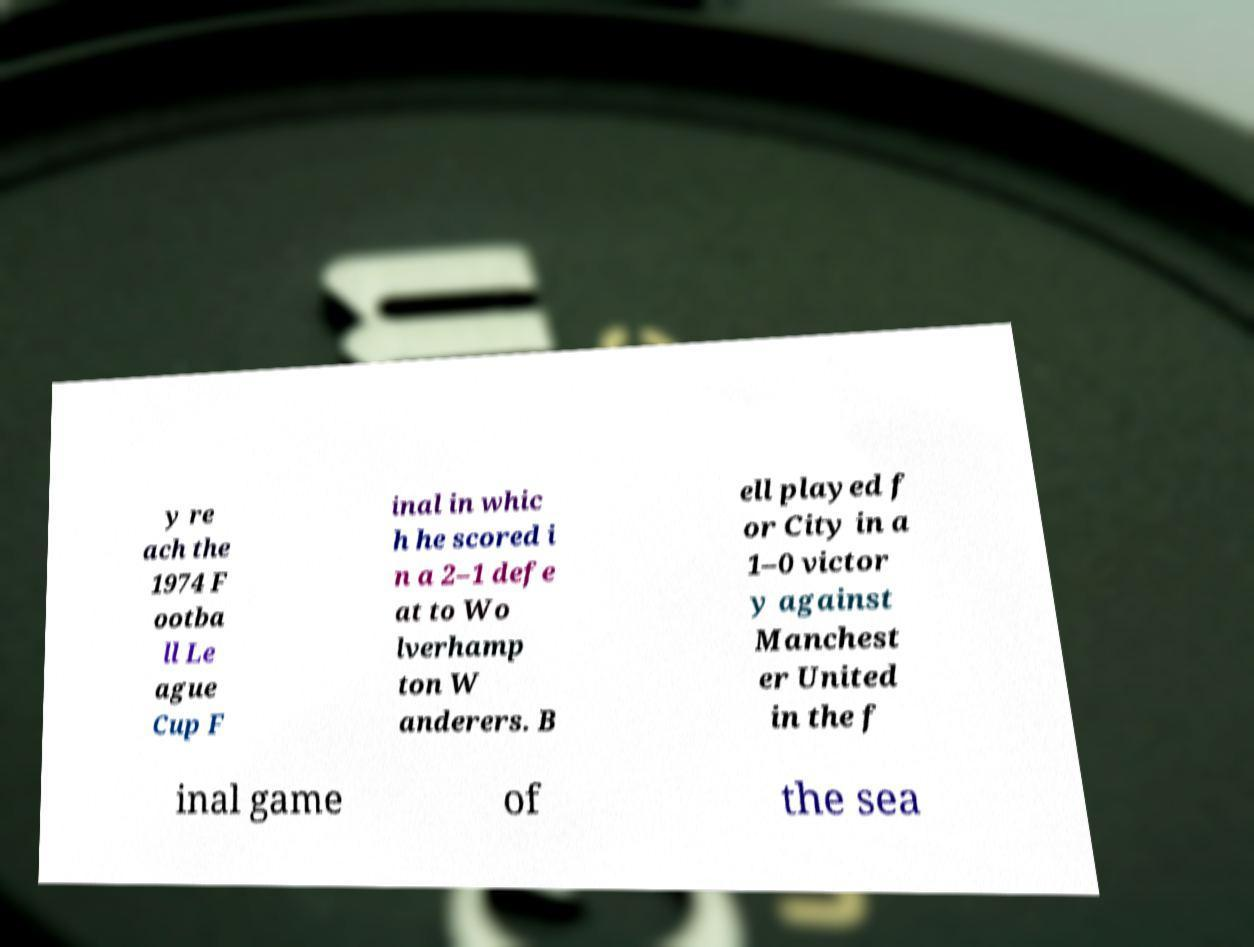Please read and relay the text visible in this image. What does it say? y re ach the 1974 F ootba ll Le ague Cup F inal in whic h he scored i n a 2–1 defe at to Wo lverhamp ton W anderers. B ell played f or City in a 1–0 victor y against Manchest er United in the f inal game of the sea 